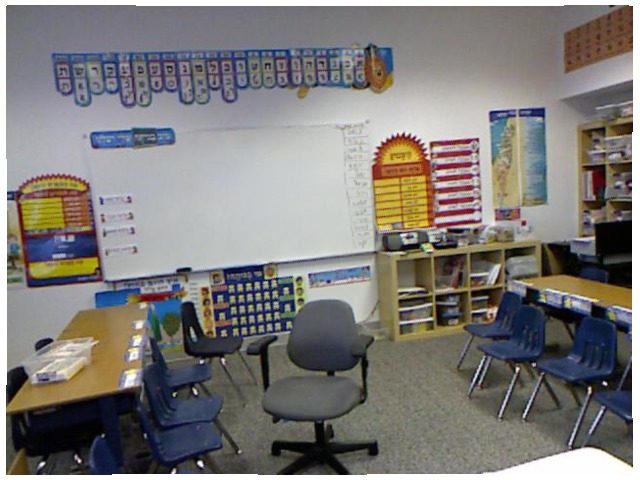<image>
Is there a numbers on the wall? Yes. Looking at the image, I can see the numbers is positioned on top of the wall, with the wall providing support. Where is the storage box in relation to the table? Is it on the table? Yes. Looking at the image, I can see the storage box is positioned on top of the table, with the table providing support. Where is the table in relation to the chair? Is it behind the chair? Yes. From this viewpoint, the table is positioned behind the chair, with the chair partially or fully occluding the table. 